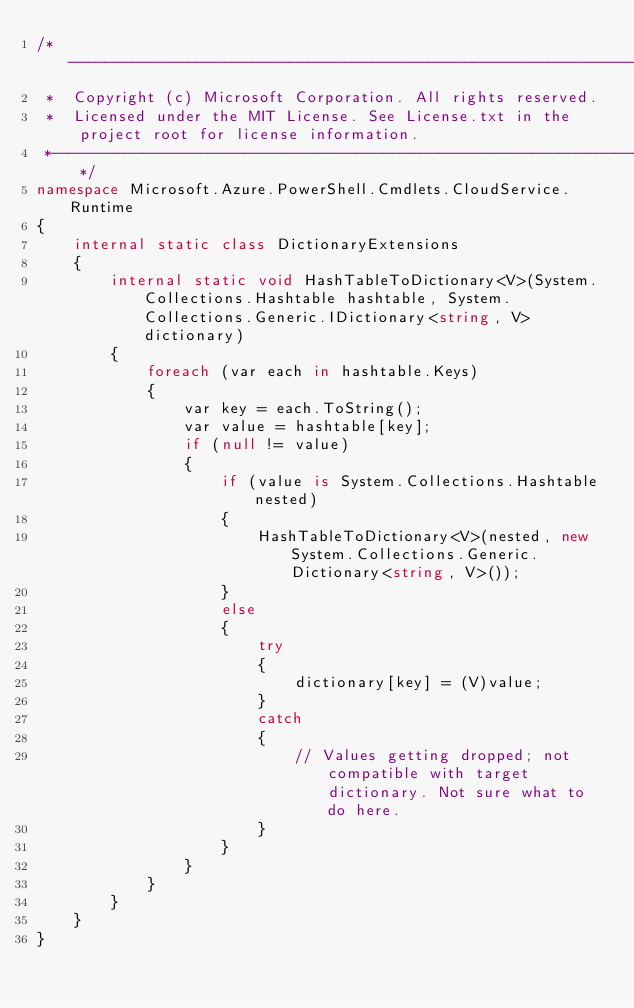Convert code to text. <code><loc_0><loc_0><loc_500><loc_500><_C#_>/*---------------------------------------------------------------------------------------------
 *  Copyright (c) Microsoft Corporation. All rights reserved.
 *  Licensed under the MIT License. See License.txt in the project root for license information.
 *--------------------------------------------------------------------------------------------*/
namespace Microsoft.Azure.PowerShell.Cmdlets.CloudService.Runtime
{
    internal static class DictionaryExtensions
    {
        internal static void HashTableToDictionary<V>(System.Collections.Hashtable hashtable, System.Collections.Generic.IDictionary<string, V> dictionary)
        {
            foreach (var each in hashtable.Keys)
            {
                var key = each.ToString();
                var value = hashtable[key];
                if (null != value)
                {
                    if (value is System.Collections.Hashtable nested)
                    {
                        HashTableToDictionary<V>(nested, new System.Collections.Generic.Dictionary<string, V>());
                    }
                    else
                    {
                        try
                        {
                            dictionary[key] = (V)value;
                        }
                        catch
                        {
                            // Values getting dropped; not compatible with target dictionary. Not sure what to do here.
                        }
                    }
                }
            }
        }
    }
}</code> 